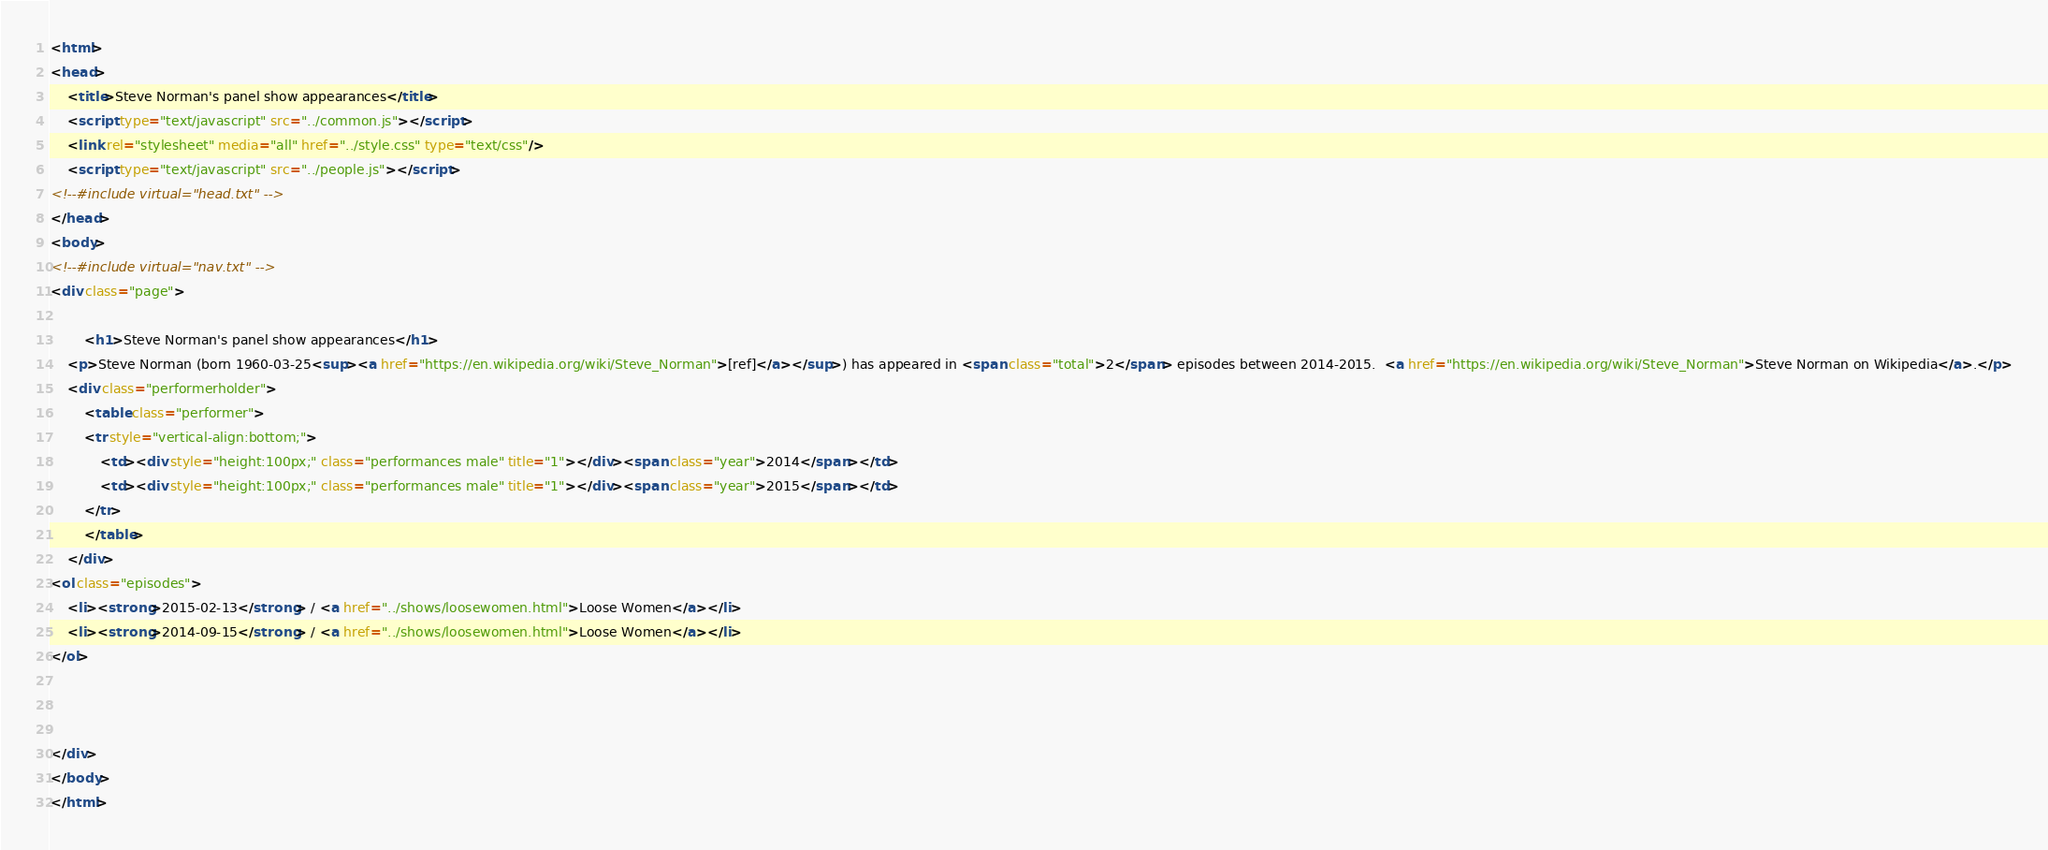Convert code to text. <code><loc_0><loc_0><loc_500><loc_500><_HTML_><html>
<head>
	<title>Steve Norman's panel show appearances</title>
	<script type="text/javascript" src="../common.js"></script>
	<link rel="stylesheet" media="all" href="../style.css" type="text/css"/>
	<script type="text/javascript" src="../people.js"></script>
<!--#include virtual="head.txt" -->
</head>
<body>
<!--#include virtual="nav.txt" -->
<div class="page">

		<h1>Steve Norman's panel show appearances</h1>
	<p>Steve Norman (born 1960-03-25<sup><a href="https://en.wikipedia.org/wiki/Steve_Norman">[ref]</a></sup>) has appeared in <span class="total">2</span> episodes between 2014-2015.  <a href="https://en.wikipedia.org/wiki/Steve_Norman">Steve Norman on Wikipedia</a>.</p>
	<div class="performerholder">
		<table class="performer">
		<tr style="vertical-align:bottom;">
			<td><div style="height:100px;" class="performances male" title="1"></div><span class="year">2014</span></td>
			<td><div style="height:100px;" class="performances male" title="1"></div><span class="year">2015</span></td>
		</tr>
		</table>
	</div>
<ol class="episodes">
	<li><strong>2015-02-13</strong> / <a href="../shows/loosewomen.html">Loose Women</a></li>
	<li><strong>2014-09-15</strong> / <a href="../shows/loosewomen.html">Loose Women</a></li>
</ol>



</div>
</body>
</html>
</code> 